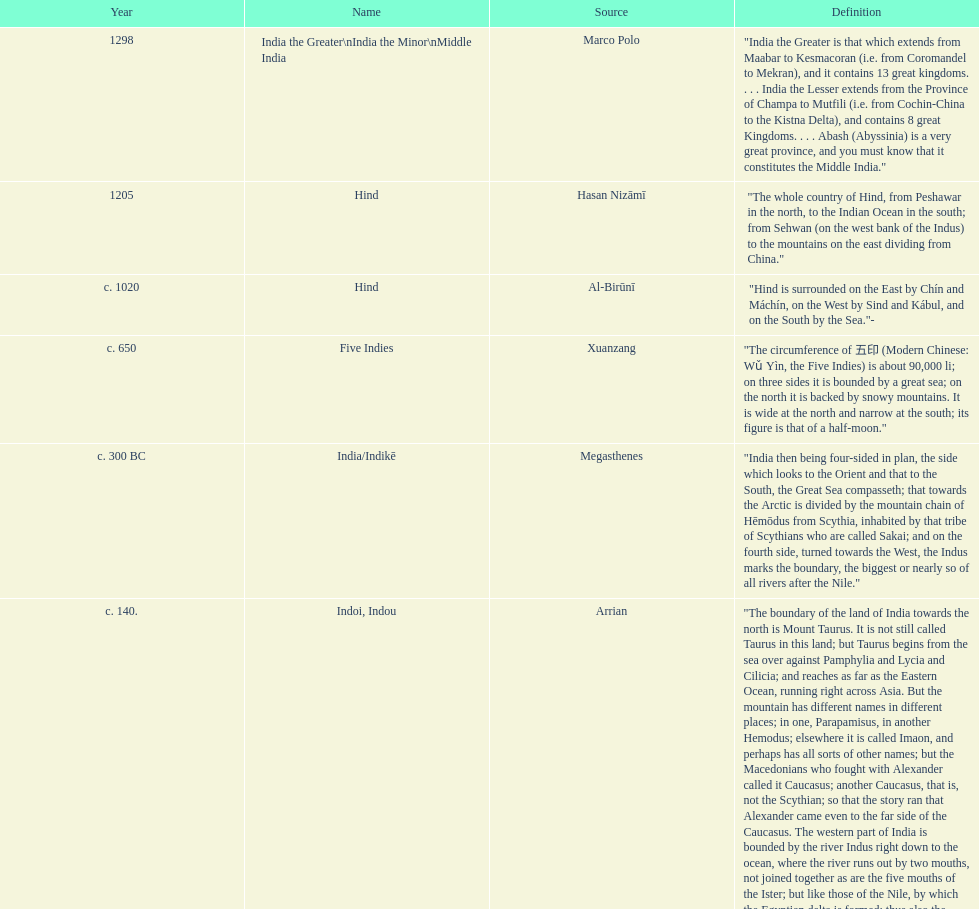What was the nation called before the book of esther called it hodu? Hidush. 